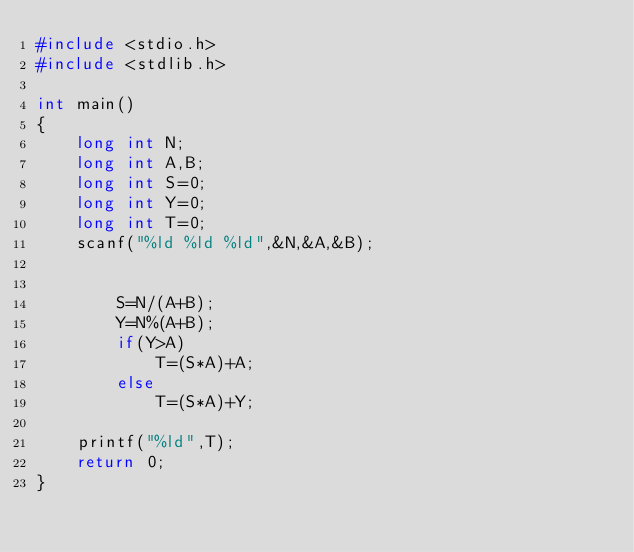<code> <loc_0><loc_0><loc_500><loc_500><_C_>#include <stdio.h>
#include <stdlib.h>

int main()
{
    long int N;
    long int A,B;
    long int S=0;
    long int Y=0;
    long int T=0;
    scanf("%ld %ld %ld",&N,&A,&B);


        S=N/(A+B);
        Y=N%(A+B);
        if(Y>A)
            T=(S*A)+A;
        else
            T=(S*A)+Y;

    printf("%ld",T);
    return 0;
}</code> 